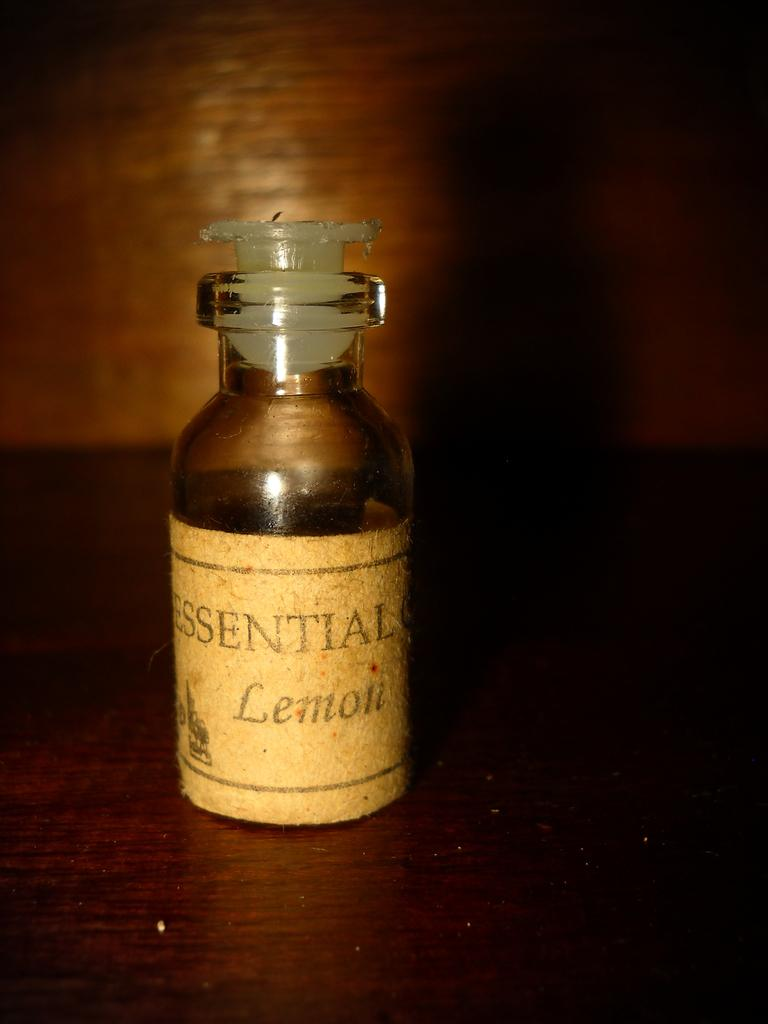<image>
Share a concise interpretation of the image provided. A bottle of essential oils with the label Lemon. 